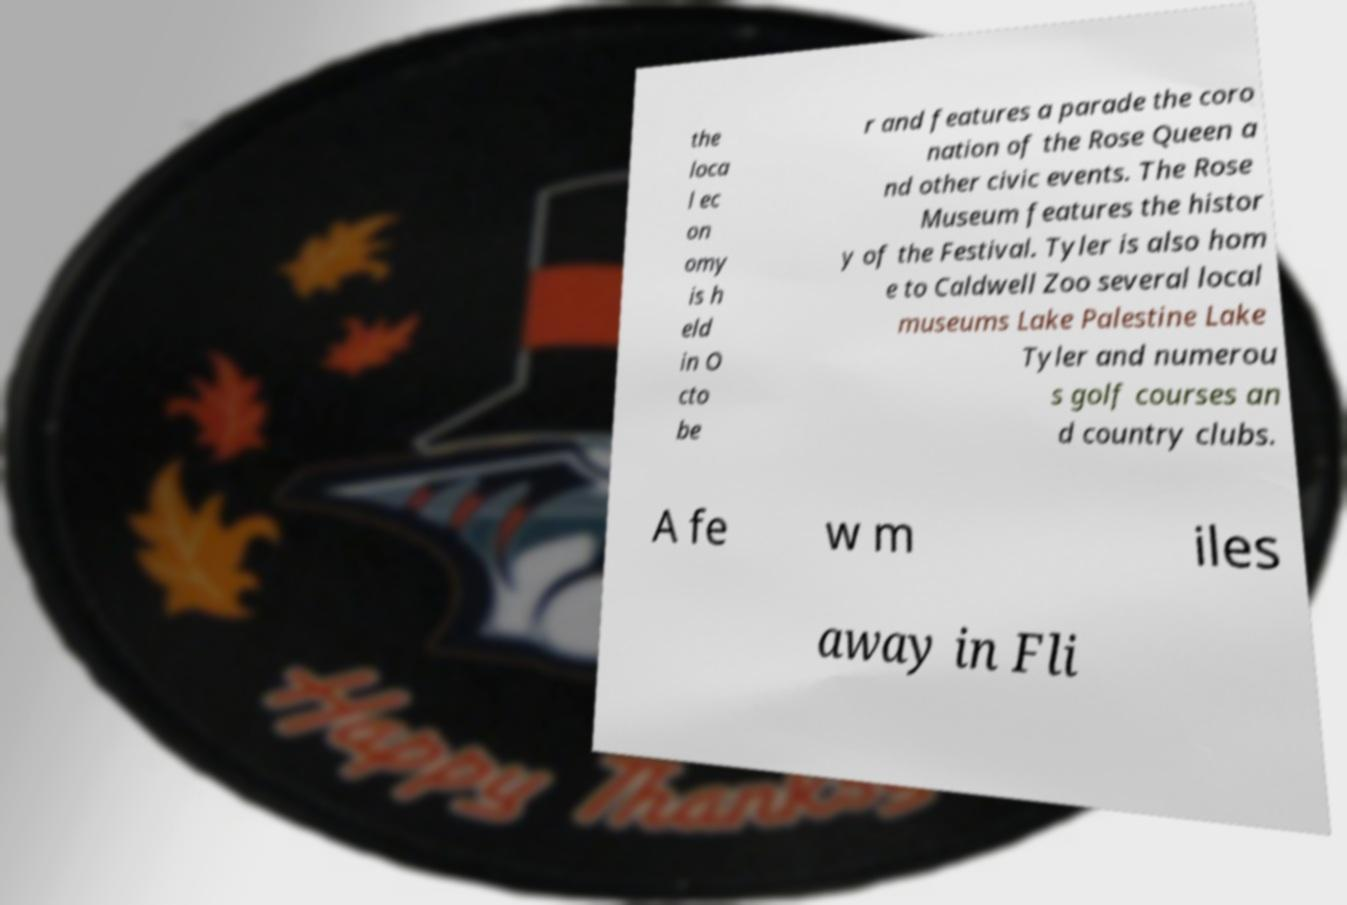Can you read and provide the text displayed in the image?This photo seems to have some interesting text. Can you extract and type it out for me? the loca l ec on omy is h eld in O cto be r and features a parade the coro nation of the Rose Queen a nd other civic events. The Rose Museum features the histor y of the Festival. Tyler is also hom e to Caldwell Zoo several local museums Lake Palestine Lake Tyler and numerou s golf courses an d country clubs. A fe w m iles away in Fli 